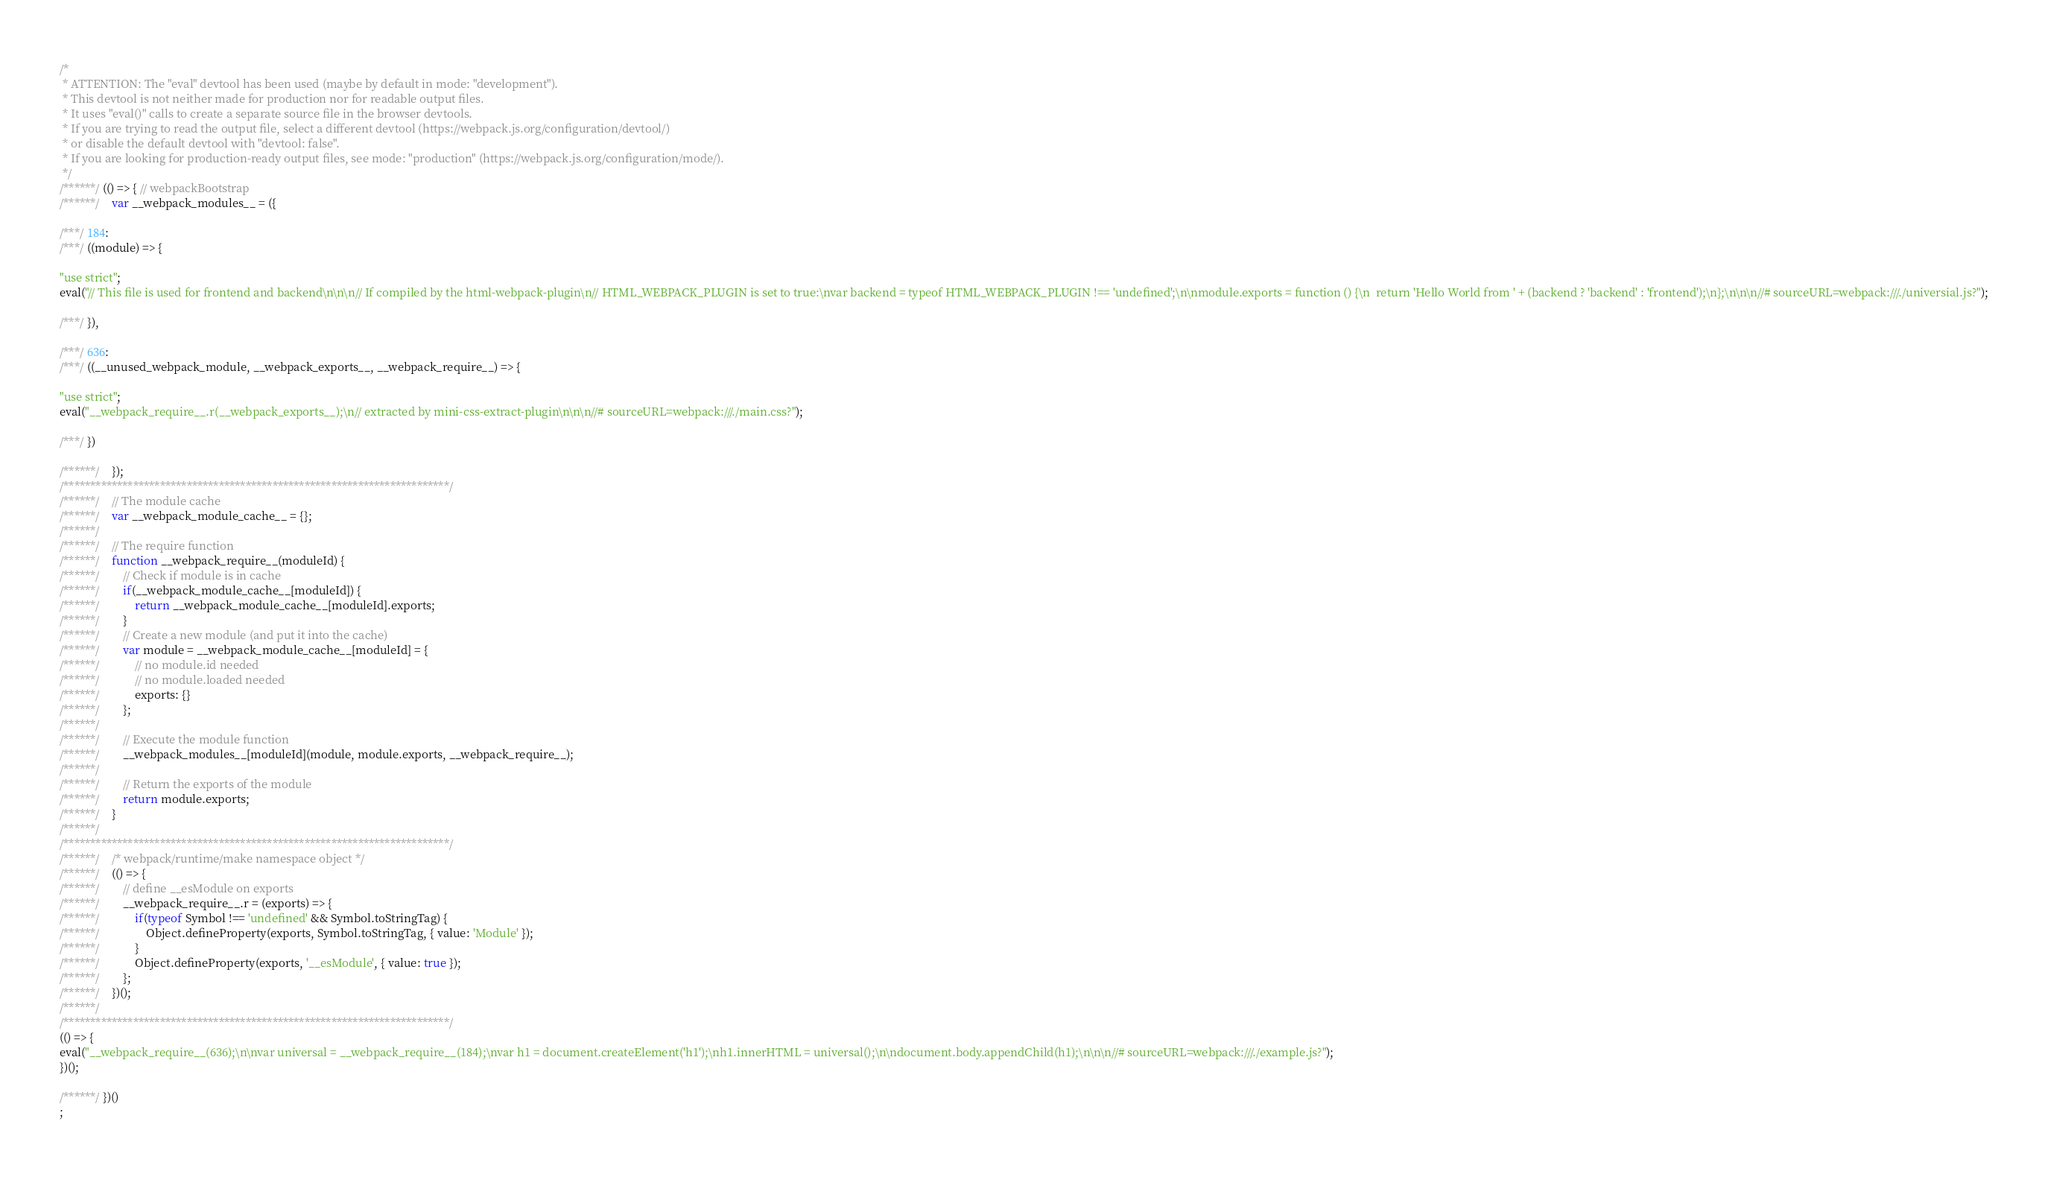<code> <loc_0><loc_0><loc_500><loc_500><_JavaScript_>/*
 * ATTENTION: The "eval" devtool has been used (maybe by default in mode: "development").
 * This devtool is not neither made for production nor for readable output files.
 * It uses "eval()" calls to create a separate source file in the browser devtools.
 * If you are trying to read the output file, select a different devtool (https://webpack.js.org/configuration/devtool/)
 * or disable the default devtool with "devtool: false".
 * If you are looking for production-ready output files, see mode: "production" (https://webpack.js.org/configuration/mode/).
 */
/******/ (() => { // webpackBootstrap
/******/ 	var __webpack_modules__ = ({

/***/ 184:
/***/ ((module) => {

"use strict";
eval("// This file is used for frontend and backend\n\n\n// If compiled by the html-webpack-plugin\n// HTML_WEBPACK_PLUGIN is set to true:\nvar backend = typeof HTML_WEBPACK_PLUGIN !== 'undefined';\n\nmodule.exports = function () {\n  return 'Hello World from ' + (backend ? 'backend' : 'frontend');\n};\n\n\n//# sourceURL=webpack:///./universial.js?");

/***/ }),

/***/ 636:
/***/ ((__unused_webpack_module, __webpack_exports__, __webpack_require__) => {

"use strict";
eval("__webpack_require__.r(__webpack_exports__);\n// extracted by mini-css-extract-plugin\n\n\n//# sourceURL=webpack:///./main.css?");

/***/ })

/******/ 	});
/************************************************************************/
/******/ 	// The module cache
/******/ 	var __webpack_module_cache__ = {};
/******/ 	
/******/ 	// The require function
/******/ 	function __webpack_require__(moduleId) {
/******/ 		// Check if module is in cache
/******/ 		if(__webpack_module_cache__[moduleId]) {
/******/ 			return __webpack_module_cache__[moduleId].exports;
/******/ 		}
/******/ 		// Create a new module (and put it into the cache)
/******/ 		var module = __webpack_module_cache__[moduleId] = {
/******/ 			// no module.id needed
/******/ 			// no module.loaded needed
/******/ 			exports: {}
/******/ 		};
/******/ 	
/******/ 		// Execute the module function
/******/ 		__webpack_modules__[moduleId](module, module.exports, __webpack_require__);
/******/ 	
/******/ 		// Return the exports of the module
/******/ 		return module.exports;
/******/ 	}
/******/ 	
/************************************************************************/
/******/ 	/* webpack/runtime/make namespace object */
/******/ 	(() => {
/******/ 		// define __esModule on exports
/******/ 		__webpack_require__.r = (exports) => {
/******/ 			if(typeof Symbol !== 'undefined' && Symbol.toStringTag) {
/******/ 				Object.defineProperty(exports, Symbol.toStringTag, { value: 'Module' });
/******/ 			}
/******/ 			Object.defineProperty(exports, '__esModule', { value: true });
/******/ 		};
/******/ 	})();
/******/ 	
/************************************************************************/
(() => {
eval("__webpack_require__(636);\n\nvar universal = __webpack_require__(184);\nvar h1 = document.createElement('h1');\nh1.innerHTML = universal();\n\ndocument.body.appendChild(h1);\n\n\n//# sourceURL=webpack:///./example.js?");
})();

/******/ })()
;</code> 